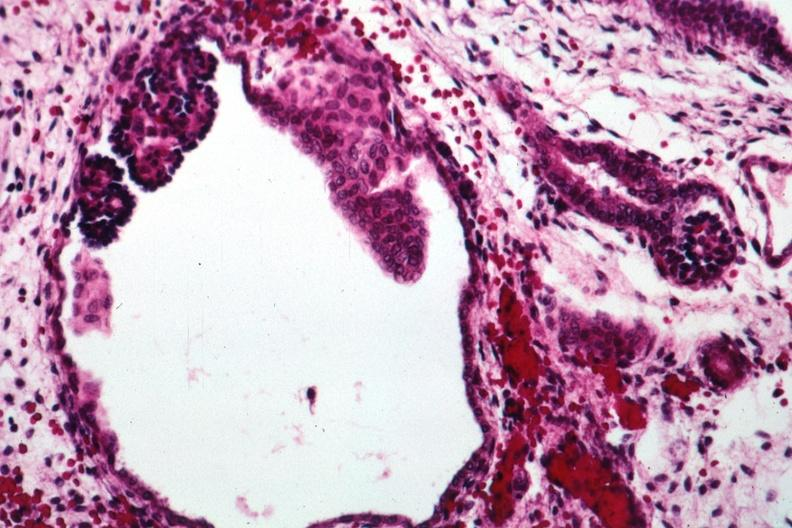s polycystic disease infant present?
Answer the question using a single word or phrase. Yes 